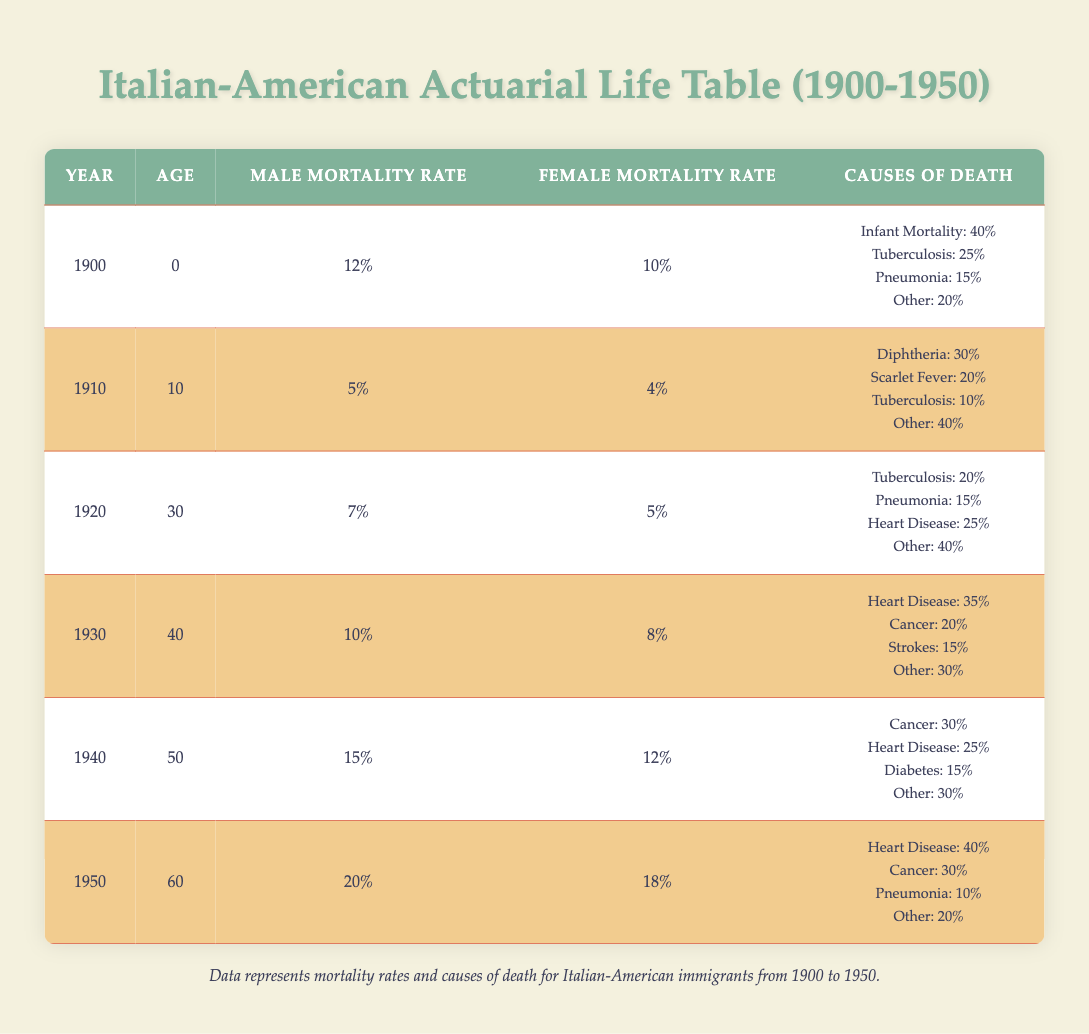What was the male mortality rate in 1940? From the table, the male mortality rate for the year 1940 is listed directly next to that year in the "Male Mortality Rate" column as 15%.
Answer: 15% What percentage of female mortality in 1900 was due to tuberculosis? The table indicates that in 1900, the female mortality rate was 10%, with tuberculosis accounting for 25% of the cause of death. Therefore, the calculation is 25% of 10%, which is 2.5%.
Answer: 2.5% Is the mortality rate for males higher in 1950 than it was in 1940? In 1940, the male mortality rate was 15%, and in 1950, it rose to 20%. Since 20% is greater than 15%, the answer is yes.
Answer: Yes What is the average male mortality rate from 1900 to 1950? To find the average, we sum the male mortality rates: 12% + 5% + 7% + 10% + 15% + 20% = 69%. Since there are 6 data points, divide by 6 to find the average: 69% / 6 = 11.5%.
Answer: 11.5% What was the most common cause of death for males in 1930? Looking at the entries for 1930, the causes of death listed are heart disease (35%), cancer (20%), strokes (15%), and other (30%). Heart disease has the highest percentage.
Answer: Heart disease Which cause of death had the lowest percentage for females in 1920? The table notes that in 1920, the causes of death for females included tuberculosis (20%), pneumonia (15%), heart disease (25%), and other (40%). Pneumonia has the lowest percentage at 15%.
Answer: Pneumonia How many different causes of death are listed for 1940 and what are their percentages? In the year 1940, four causes of death are listed: cancer (30%), heart disease (25%), diabetes (15%), and other (30%). Thus, there are four causes with the respective percentages.
Answer: Four causes: cancer 30%, heart disease 25%, diabetes 15%, other 30% What trend can be observed from male mortality rates from 1900 to 1950? Reviewing the data, male mortality rates increased from 12% in 1900 to 20% in 1950, indicating a rising trend over the 50 years.
Answer: Increasing trend 